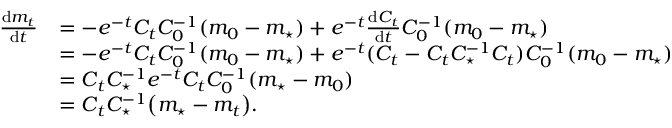Convert formula to latex. <formula><loc_0><loc_0><loc_500><loc_500>\begin{array} { r l } { \frac { d m _ { t } } { d t } } & { = - e ^ { - t } C _ { t } C _ { 0 } ^ { - 1 } ( m _ { 0 } - m _ { ^ { * } } ) + e ^ { - t } \frac { d C _ { t } } { d t } C _ { 0 } ^ { - 1 } ( m _ { 0 } - m _ { ^ { * } } ) } \\ & { = - e ^ { - t } C _ { t } C _ { 0 } ^ { - 1 } ( m _ { 0 } - m _ { ^ { * } } ) + e ^ { - t } ( C _ { t } - C _ { t } C _ { ^ { * } } ^ { - 1 } C _ { t } ) C _ { 0 } ^ { - 1 } ( m _ { 0 } - m _ { ^ { * } } ) } \\ & { = C _ { t } C _ { ^ { * } } ^ { - 1 } e ^ { - t } C _ { t } C _ { 0 } ^ { - 1 } ( m _ { ^ { * } } - m _ { 0 } ) } \\ & { = C _ { t } C _ { ^ { * } } ^ { - 1 } \left ( m _ { ^ { * } } - m _ { t } \right ) . } \end{array}</formula> 